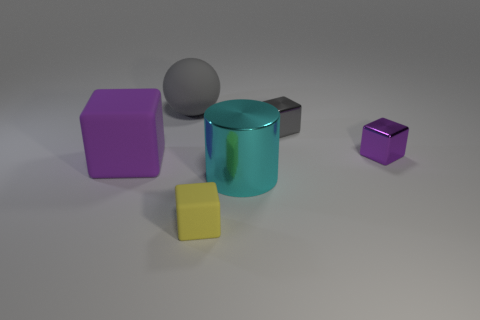Subtract all red cylinders. How many purple blocks are left? 2 Subtract all purple metal cubes. How many cubes are left? 3 Add 3 big shiny cylinders. How many objects exist? 9 Subtract all yellow blocks. How many blocks are left? 3 Subtract all blocks. How many objects are left? 2 Subtract all gray cubes. Subtract all gray cylinders. How many cubes are left? 3 Subtract all small purple things. Subtract all big cyan metallic cylinders. How many objects are left? 4 Add 2 large purple matte objects. How many large purple matte objects are left? 3 Add 3 tiny yellow cubes. How many tiny yellow cubes exist? 4 Subtract 0 purple cylinders. How many objects are left? 6 